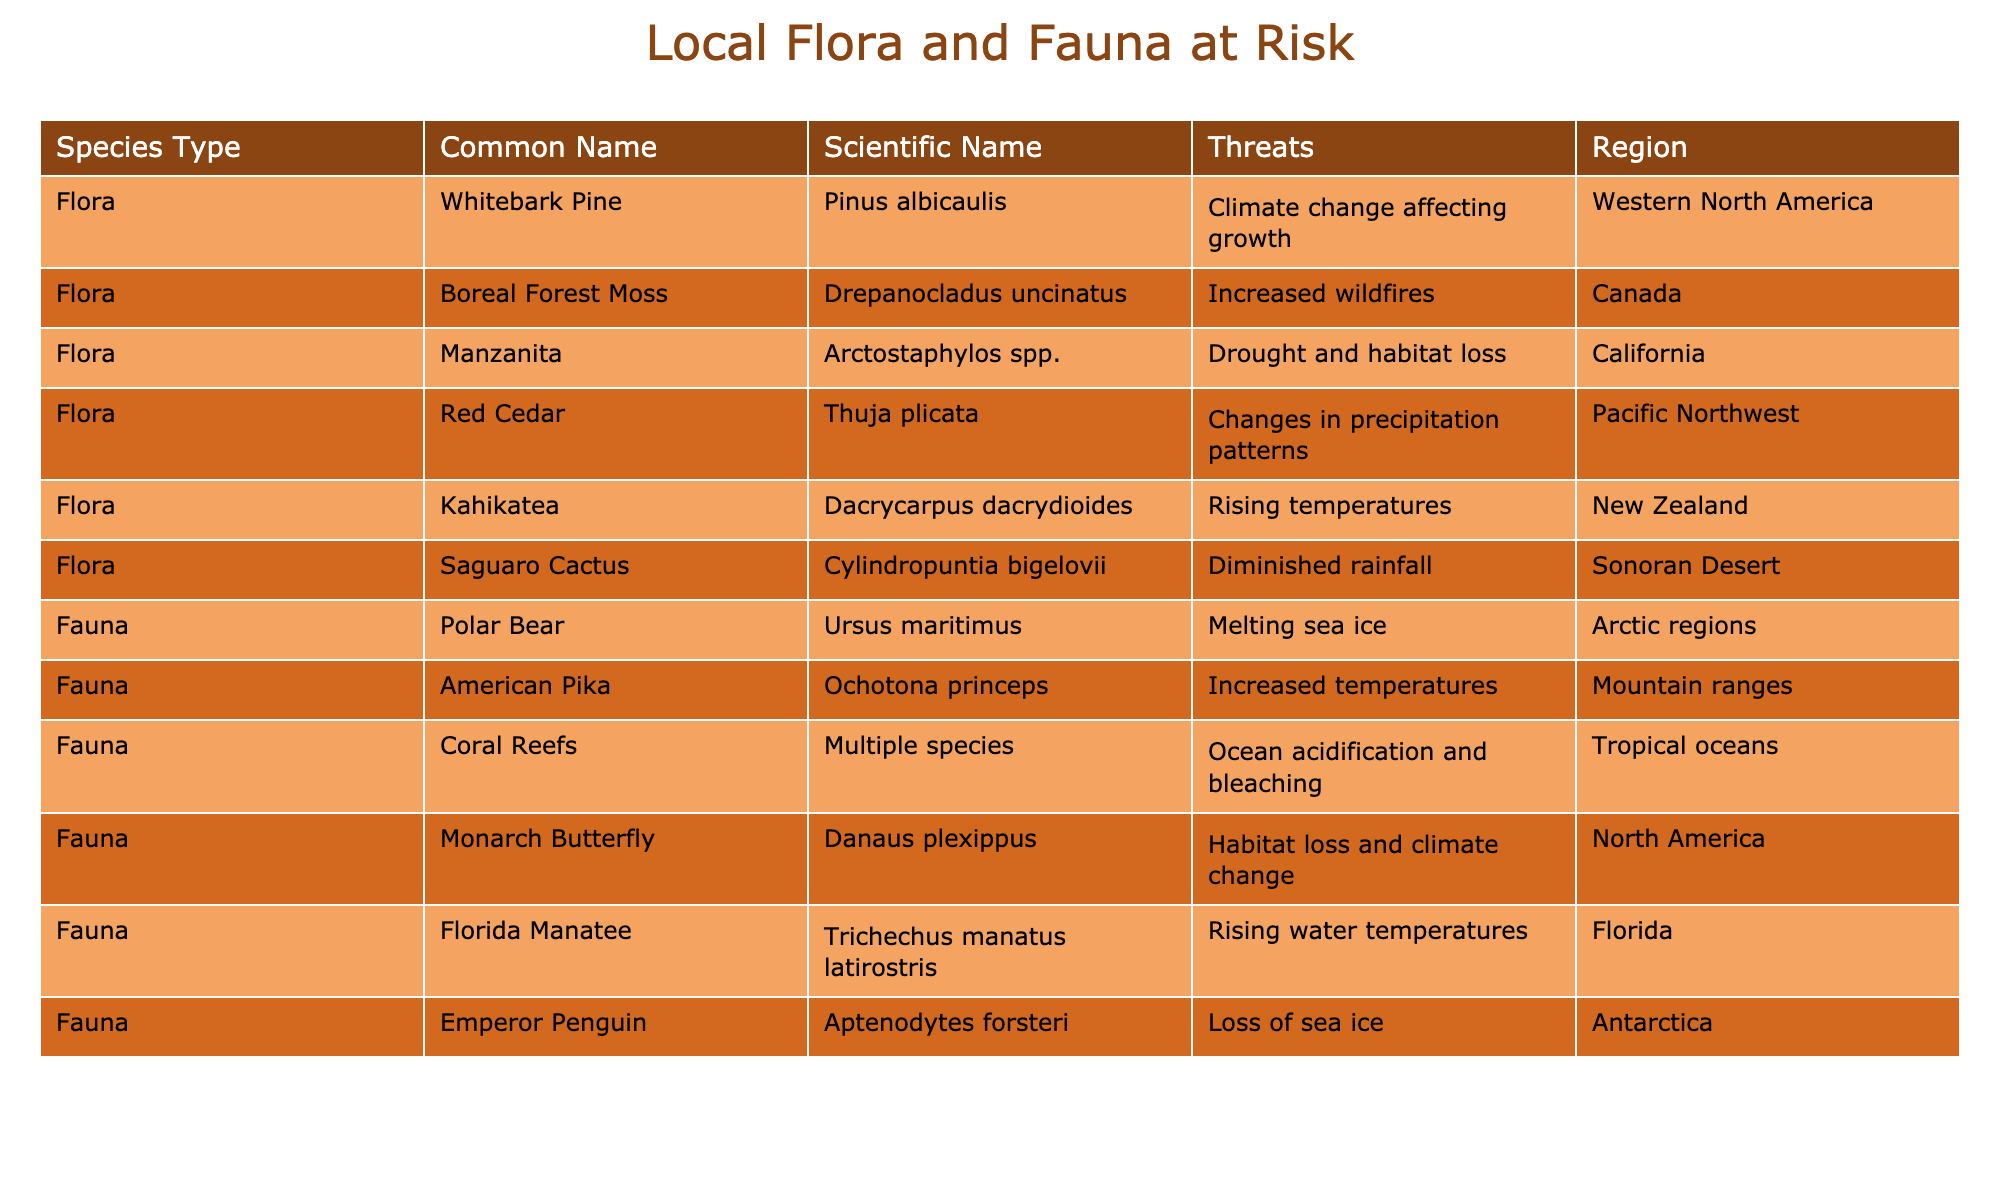What is the scientific name of the Polar Bear? The table lists the common name and scientific name for various species. Looking under the Fauna section, the Polar Bear's scientific name is found next to its common name.
Answer: Ursus maritimus Which flora species is threatened by drought and habitat loss? The table categorizes species by type and lists the threats they face. Filtering for the Flora section, Manzanita is specifically noted to be affected by drought and habitat loss.
Answer: Manzanita How many species in the Fauna section are affected by rising temperatures? In the Fauna section, I will count how many species mention rising temperatures as a threat. The Florida Manatee and Emperor Penguin both list rising temperatures in their threats. Therefore, there are two species.
Answer: 2 Are Coral Reefs at risk due to melting sea ice? Looking at the table, Coral Reefs are affected by ocean acidification and bleaching, not melting sea ice. The Polar Bear is the one at risk from melting sea ice, so the statement is false.
Answer: No Which region is most at risk for the impact on Red Cedar? The table indicates that the Red Cedar is threatened by changes in precipitation patterns specifically in the Pacific Northwest region. Thus, the Pacific Northwest is identified as the most at-risk region for Red Cedar.
Answer: Pacific Northwest What is the total number of flora species mentioned in the table? To find the total number of flora species, I will count the rows in the Flora section of the table. There are five flora species listed: Whitebark Pine, Boreal Forest Moss, Manzanita, Red Cedar, and Kahikatea. Therefore, the total is five.
Answer: 5 Which species face threats from increased temperatures? I will review both Flora and Fauna categories to identify species that are facing threats due to increased temperatures. The American Pika, Kahikatea, and Florida Manatee all have increased temperatures listed as a threat.
Answer: 3 What is the primary threat to the Saguaro Cactus? Referring to the Flora section, the Saguaro Cactus is facing the threat of diminished rainfall. This is listed explicitly in the threats column of the table.
Answer: Diminished rainfall Which species is likely to be impacted by habitat loss due to climate change? I will examine the table for species that mention habitat loss as a specific threat. The Monarch Butterfly is noted to experience habitat loss and climate change as key threats.
Answer: Monarch Butterfly 